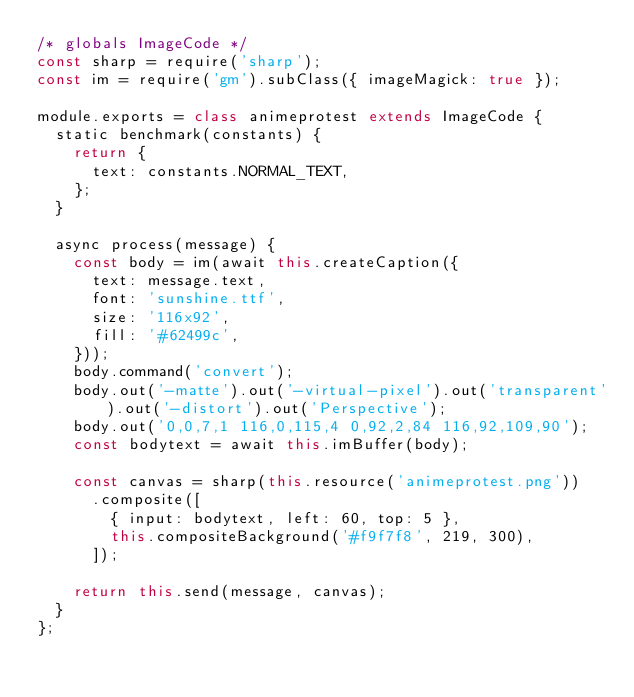<code> <loc_0><loc_0><loc_500><loc_500><_JavaScript_>/* globals ImageCode */
const sharp = require('sharp');
const im = require('gm').subClass({ imageMagick: true });

module.exports = class animeprotest extends ImageCode {
  static benchmark(constants) {
    return {
      text: constants.NORMAL_TEXT,
    };
  }

  async process(message) {
    const body = im(await this.createCaption({
      text: message.text,
      font: 'sunshine.ttf',
      size: '116x92',
      fill: '#62499c',
    }));
    body.command('convert');
    body.out('-matte').out('-virtual-pixel').out('transparent').out('-distort').out('Perspective');
    body.out('0,0,7,1 116,0,115,4 0,92,2,84 116,92,109,90');
    const bodytext = await this.imBuffer(body);

    const canvas = sharp(this.resource('animeprotest.png'))
      .composite([
        { input: bodytext, left: 60, top: 5 },
        this.compositeBackground('#f9f7f8', 219, 300),
      ]);

    return this.send(message, canvas);
  }
};</code> 